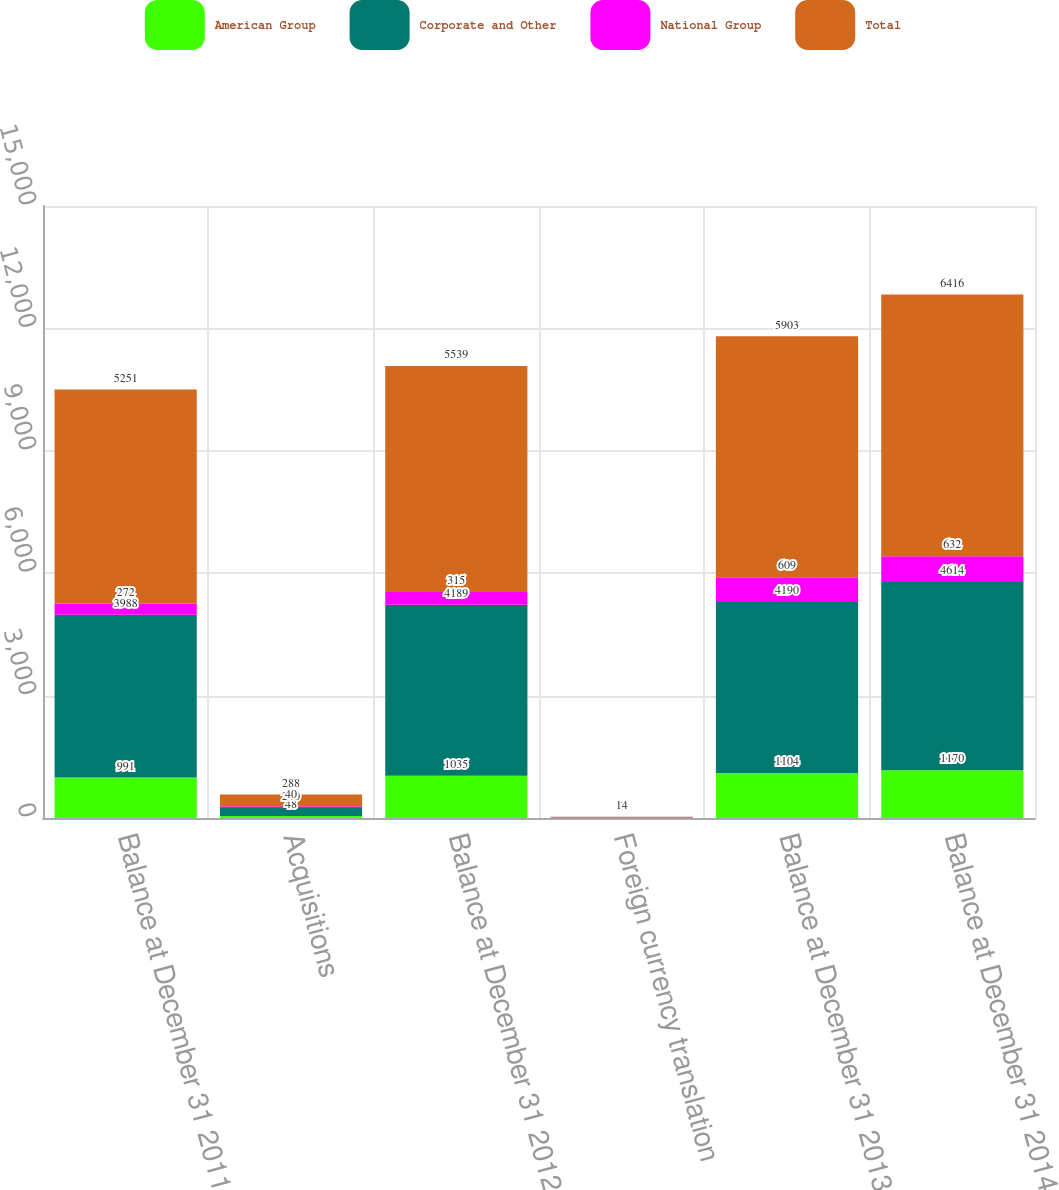Convert chart to OTSL. <chart><loc_0><loc_0><loc_500><loc_500><stacked_bar_chart><ecel><fcel>Balance at December 31 2011<fcel>Acquisitions<fcel>Balance at December 31 2012<fcel>Foreign currency translation<fcel>Balance at December 31 2013<fcel>Balance at December 31 2014<nl><fcel>American Group<fcel>991<fcel>48<fcel>1035<fcel>1<fcel>1104<fcel>1170<nl><fcel>Corporate and Other<fcel>3988<fcel>200<fcel>4189<fcel>12<fcel>4190<fcel>4614<nl><fcel>National Group<fcel>272<fcel>40<fcel>315<fcel>3<fcel>609<fcel>632<nl><fcel>Total<fcel>5251<fcel>288<fcel>5539<fcel>14<fcel>5903<fcel>6416<nl></chart> 